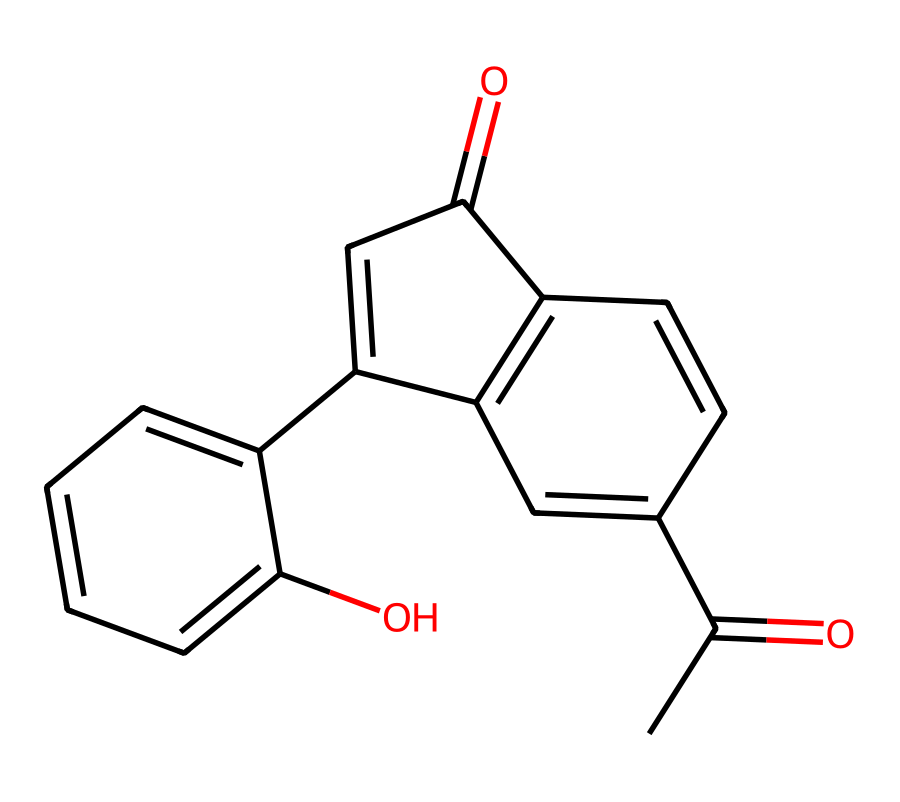What is the molecular formula of this chemical? To determine the molecular formula, we count the number of each type of atom present in the structure. By analyzing the chemical, we find it contains 15 carbons (C), 14 hydrogens (H), and 4 oxygens (O). This gives us the molecular formula C15H14O4.
Answer: C15H14O4 How many rings are present in this structure? By closely examining the chemical structure, we identify the presence of two distinct ring systems. Counting these, we see there are 2 rings in total.
Answer: 2 What functional groups are identified in this chemical? After reviewing the structure, we notice the presence of two carbonyl groups (C=O) and a hydroxyl group (-OH). These groups contribute to the chemical’s properties and behavior.
Answer: carbonyl and hydroxyl How many double bonds are in the chemical structure? Looking at the connections between atoms in the ring structures, we can identify all the double bonds. There are 4 double bonds present in the structure.
Answer: 4 Is this chemical generally classified as a steroid? The structure contains features typical of a steroid, such as a core structure composed of four fused carbon rings. This classification is confirmed by its characteristic arrangement and functional groups.
Answer: yes What is the primary use of this chemical in sports medicine? This chemical acts as a corticosteroid, which is primarily used to reduce inflammation and pain in sports injuries. This is an essential treatment aspect for athletes recovering from injuries.
Answer: to reduce inflammation 